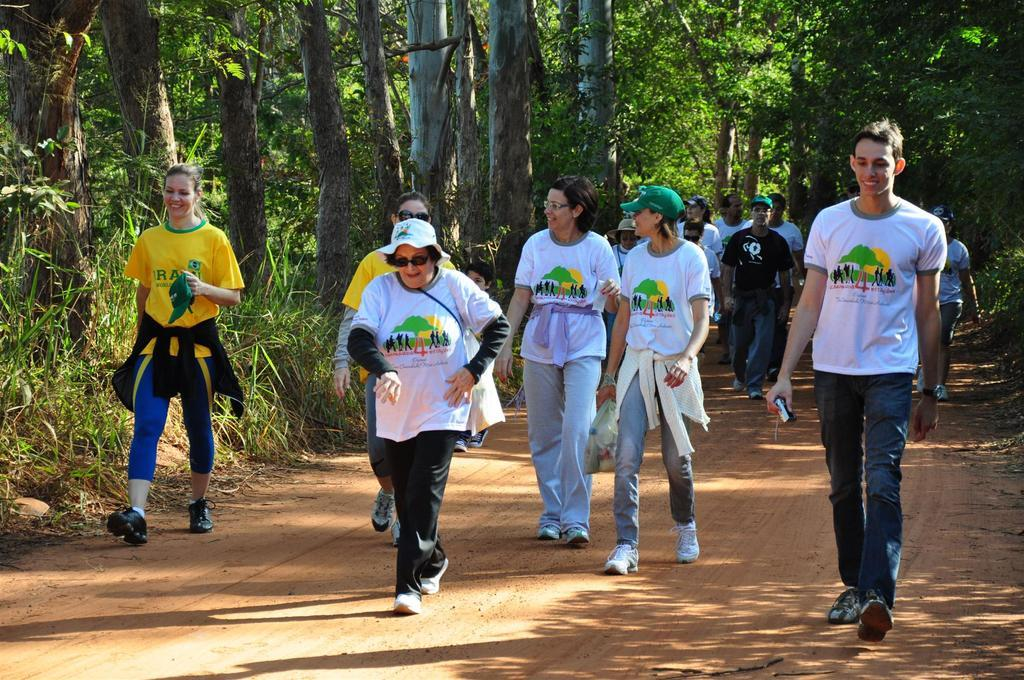Who or what can be seen in the image? There are people in the image. What are the people doing in the image? The people are walking on the ground. What are the people holding in the image? The people are holding objects. What can be seen in the distance in the image? There are trees in the background of the image. What type of brain can be seen in the image? There is no brain present in the image; it features people walking on the ground and holding objects. What game are the people playing in the image? There is no game being played in the image; the people are simply walking and holding objects. 